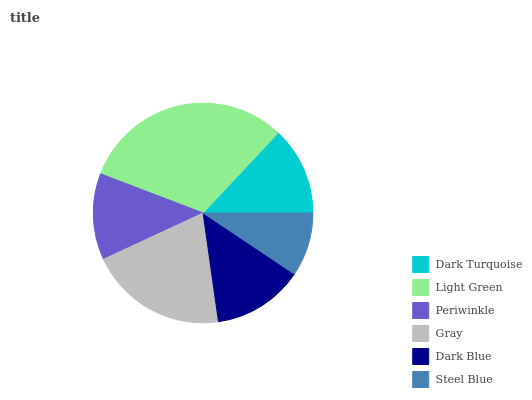Is Steel Blue the minimum?
Answer yes or no. Yes. Is Light Green the maximum?
Answer yes or no. Yes. Is Periwinkle the minimum?
Answer yes or no. No. Is Periwinkle the maximum?
Answer yes or no. No. Is Light Green greater than Periwinkle?
Answer yes or no. Yes. Is Periwinkle less than Light Green?
Answer yes or no. Yes. Is Periwinkle greater than Light Green?
Answer yes or no. No. Is Light Green less than Periwinkle?
Answer yes or no. No. Is Dark Blue the high median?
Answer yes or no. Yes. Is Dark Turquoise the low median?
Answer yes or no. Yes. Is Periwinkle the high median?
Answer yes or no. No. Is Steel Blue the low median?
Answer yes or no. No. 